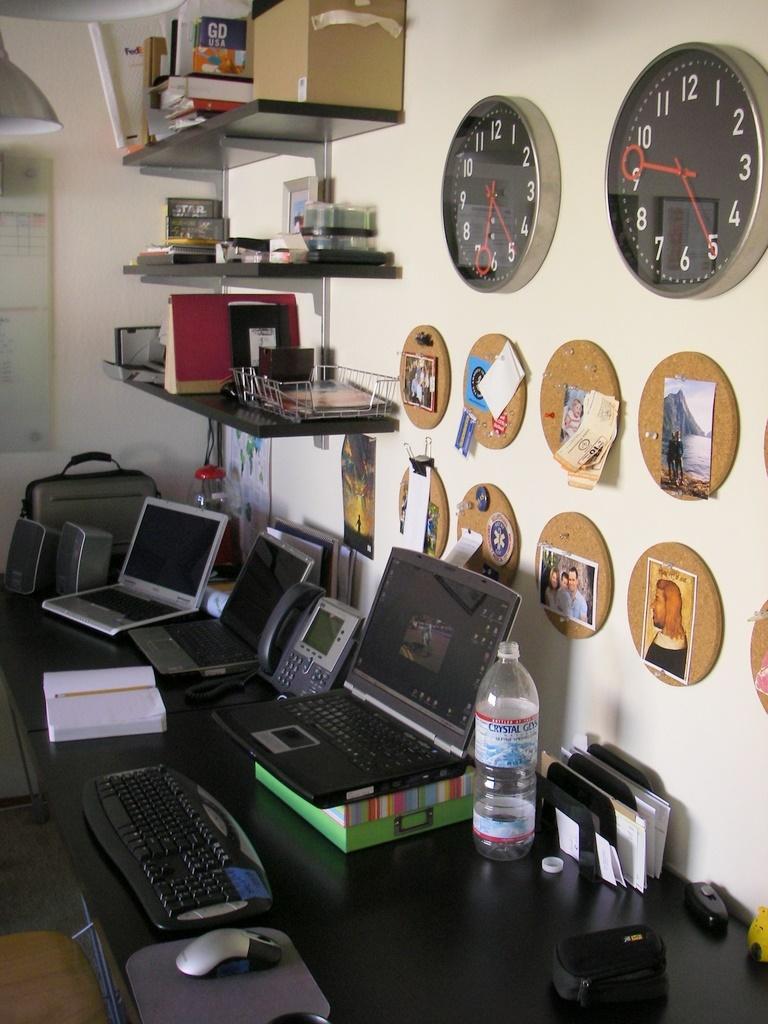Describe this image in one or two sentences. In this image there is a table with laptops, bottle and some papers, behind the table there is a wall with some photo frames and wall clocks, also there is a shelf at the corner of the room where we can see some files and other things. 